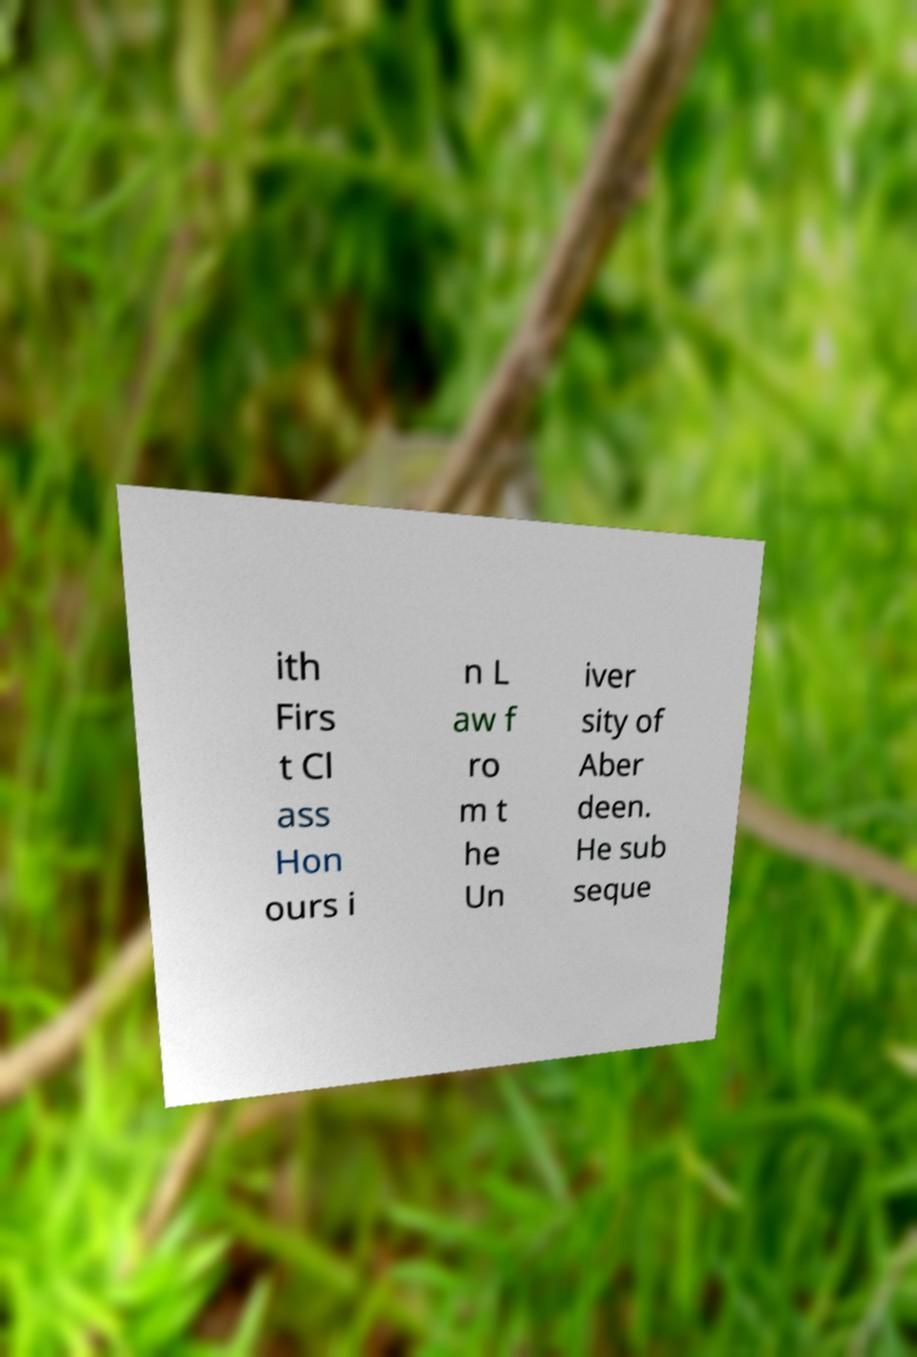Please identify and transcribe the text found in this image. ith Firs t Cl ass Hon ours i n L aw f ro m t he Un iver sity of Aber deen. He sub seque 